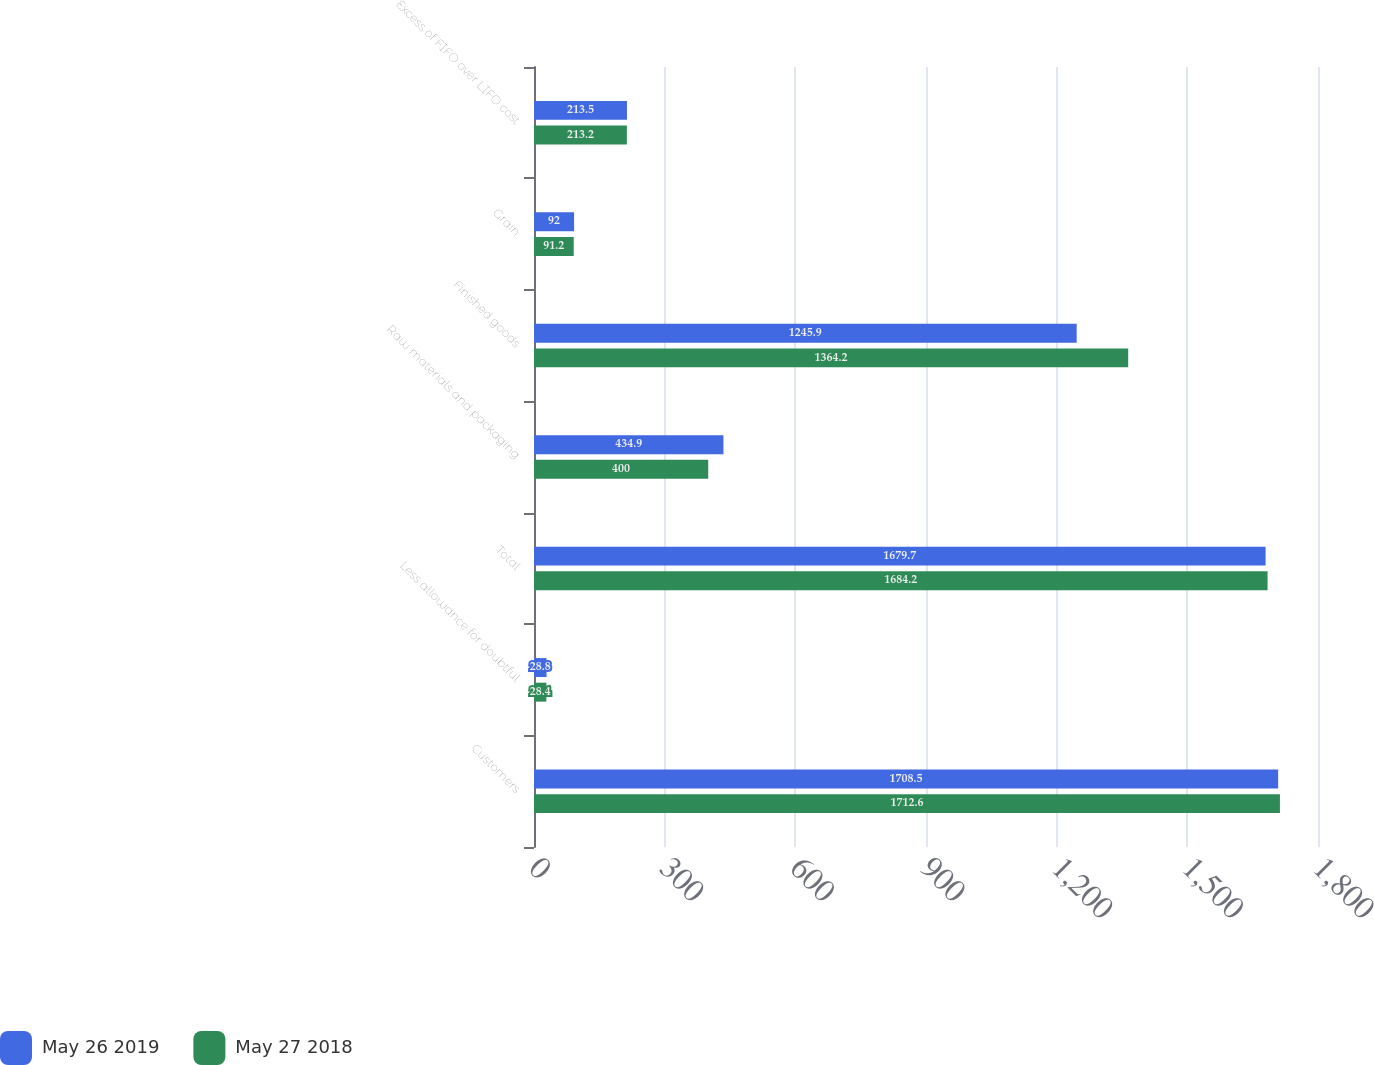<chart> <loc_0><loc_0><loc_500><loc_500><stacked_bar_chart><ecel><fcel>Customers<fcel>Less allowance for doubtful<fcel>Total<fcel>Raw materials and packaging<fcel>Finished goods<fcel>Grain<fcel>Excess of FIFO over LIFO cost<nl><fcel>May 26 2019<fcel>1708.5<fcel>28.8<fcel>1679.7<fcel>434.9<fcel>1245.9<fcel>92<fcel>213.5<nl><fcel>May 27 2018<fcel>1712.6<fcel>28.4<fcel>1684.2<fcel>400<fcel>1364.2<fcel>91.2<fcel>213.2<nl></chart> 